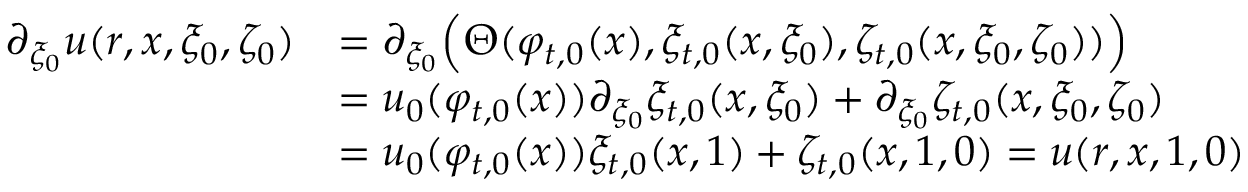<formula> <loc_0><loc_0><loc_500><loc_500>\begin{array} { r l } { \partial _ { \xi _ { 0 } } u ( r , x , \xi _ { 0 } , \zeta _ { 0 } ) } & { = \partial _ { \xi _ { 0 } } \left ( \Theta ( \varphi _ { t , 0 } ( x ) , \xi _ { t , 0 } ( x , \xi _ { 0 } ) , \zeta _ { t , 0 } ( x , \xi _ { 0 } , \zeta _ { 0 } ) ) \right ) } \\ & { = u _ { 0 } ( \varphi _ { t , 0 } ( x ) ) \partial _ { \xi _ { 0 } } \xi _ { t , 0 } ( x , \xi _ { 0 } ) + \partial _ { \xi _ { 0 } } \zeta _ { t , 0 } ( x , \xi _ { 0 } , \zeta _ { 0 } ) } \\ & { = u _ { 0 } ( \varphi _ { t , 0 } ( x ) ) \xi _ { t , 0 } ( x , 1 ) + \zeta _ { t , 0 } ( x , 1 , 0 ) = u ( r , x , 1 , 0 ) } \end{array}</formula> 